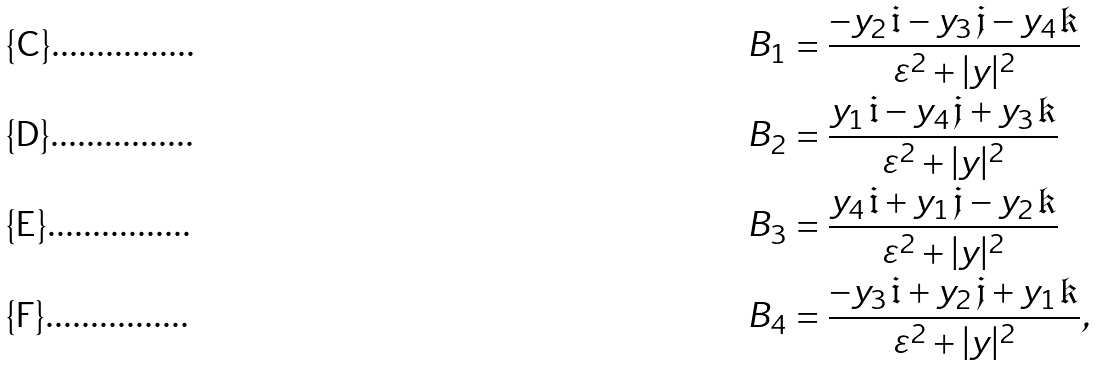Convert formula to latex. <formula><loc_0><loc_0><loc_500><loc_500>B _ { 1 } & = \frac { - y _ { 2 } \, \mathfrak { i } - y _ { 3 } \, \mathfrak { j } - y _ { 4 } \, \mathfrak { k } } { \varepsilon ^ { 2 } + | y | ^ { 2 } } \\ B _ { 2 } & = \frac { y _ { 1 } \, \mathfrak { i } - y _ { 4 } \, \mathfrak { j } + y _ { 3 } \, \mathfrak { k } } { \varepsilon ^ { 2 } + | y | ^ { 2 } } \\ B _ { 3 } & = \frac { y _ { 4 } \, \mathfrak { i } + y _ { 1 } \, \mathfrak { j } - y _ { 2 } \, \mathfrak { k } } { \varepsilon ^ { 2 } + | y | ^ { 2 } } \\ B _ { 4 } & = \frac { - y _ { 3 } \, \mathfrak { i } + y _ { 2 } \, \mathfrak { j } + y _ { 1 } \, \mathfrak { k } } { \varepsilon ^ { 2 } + | y | ^ { 2 } } ,</formula> 